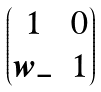Convert formula to latex. <formula><loc_0><loc_0><loc_500><loc_500>\begin{pmatrix} 1 & 0 \\ w _ { - } & 1 \end{pmatrix}</formula> 